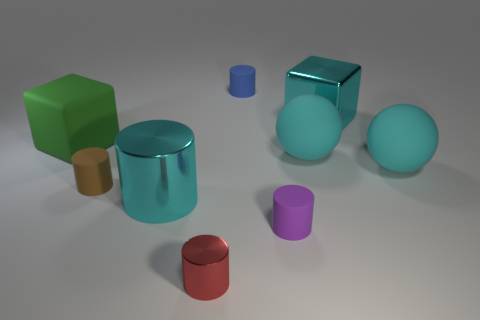Add 1 gray metallic objects. How many objects exist? 10 Subtract 1 cylinders. How many cylinders are left? 4 Subtract all cyan metal cylinders. How many cylinders are left? 4 Subtract all brown cylinders. How many cylinders are left? 4 Subtract all spheres. How many objects are left? 7 Subtract all gray cylinders. Subtract all gray spheres. How many cylinders are left? 5 Add 9 red cubes. How many red cubes exist? 9 Subtract 0 yellow cylinders. How many objects are left? 9 Subtract all large green balls. Subtract all large cyan metal cylinders. How many objects are left? 8 Add 1 cyan metallic cubes. How many cyan metallic cubes are left? 2 